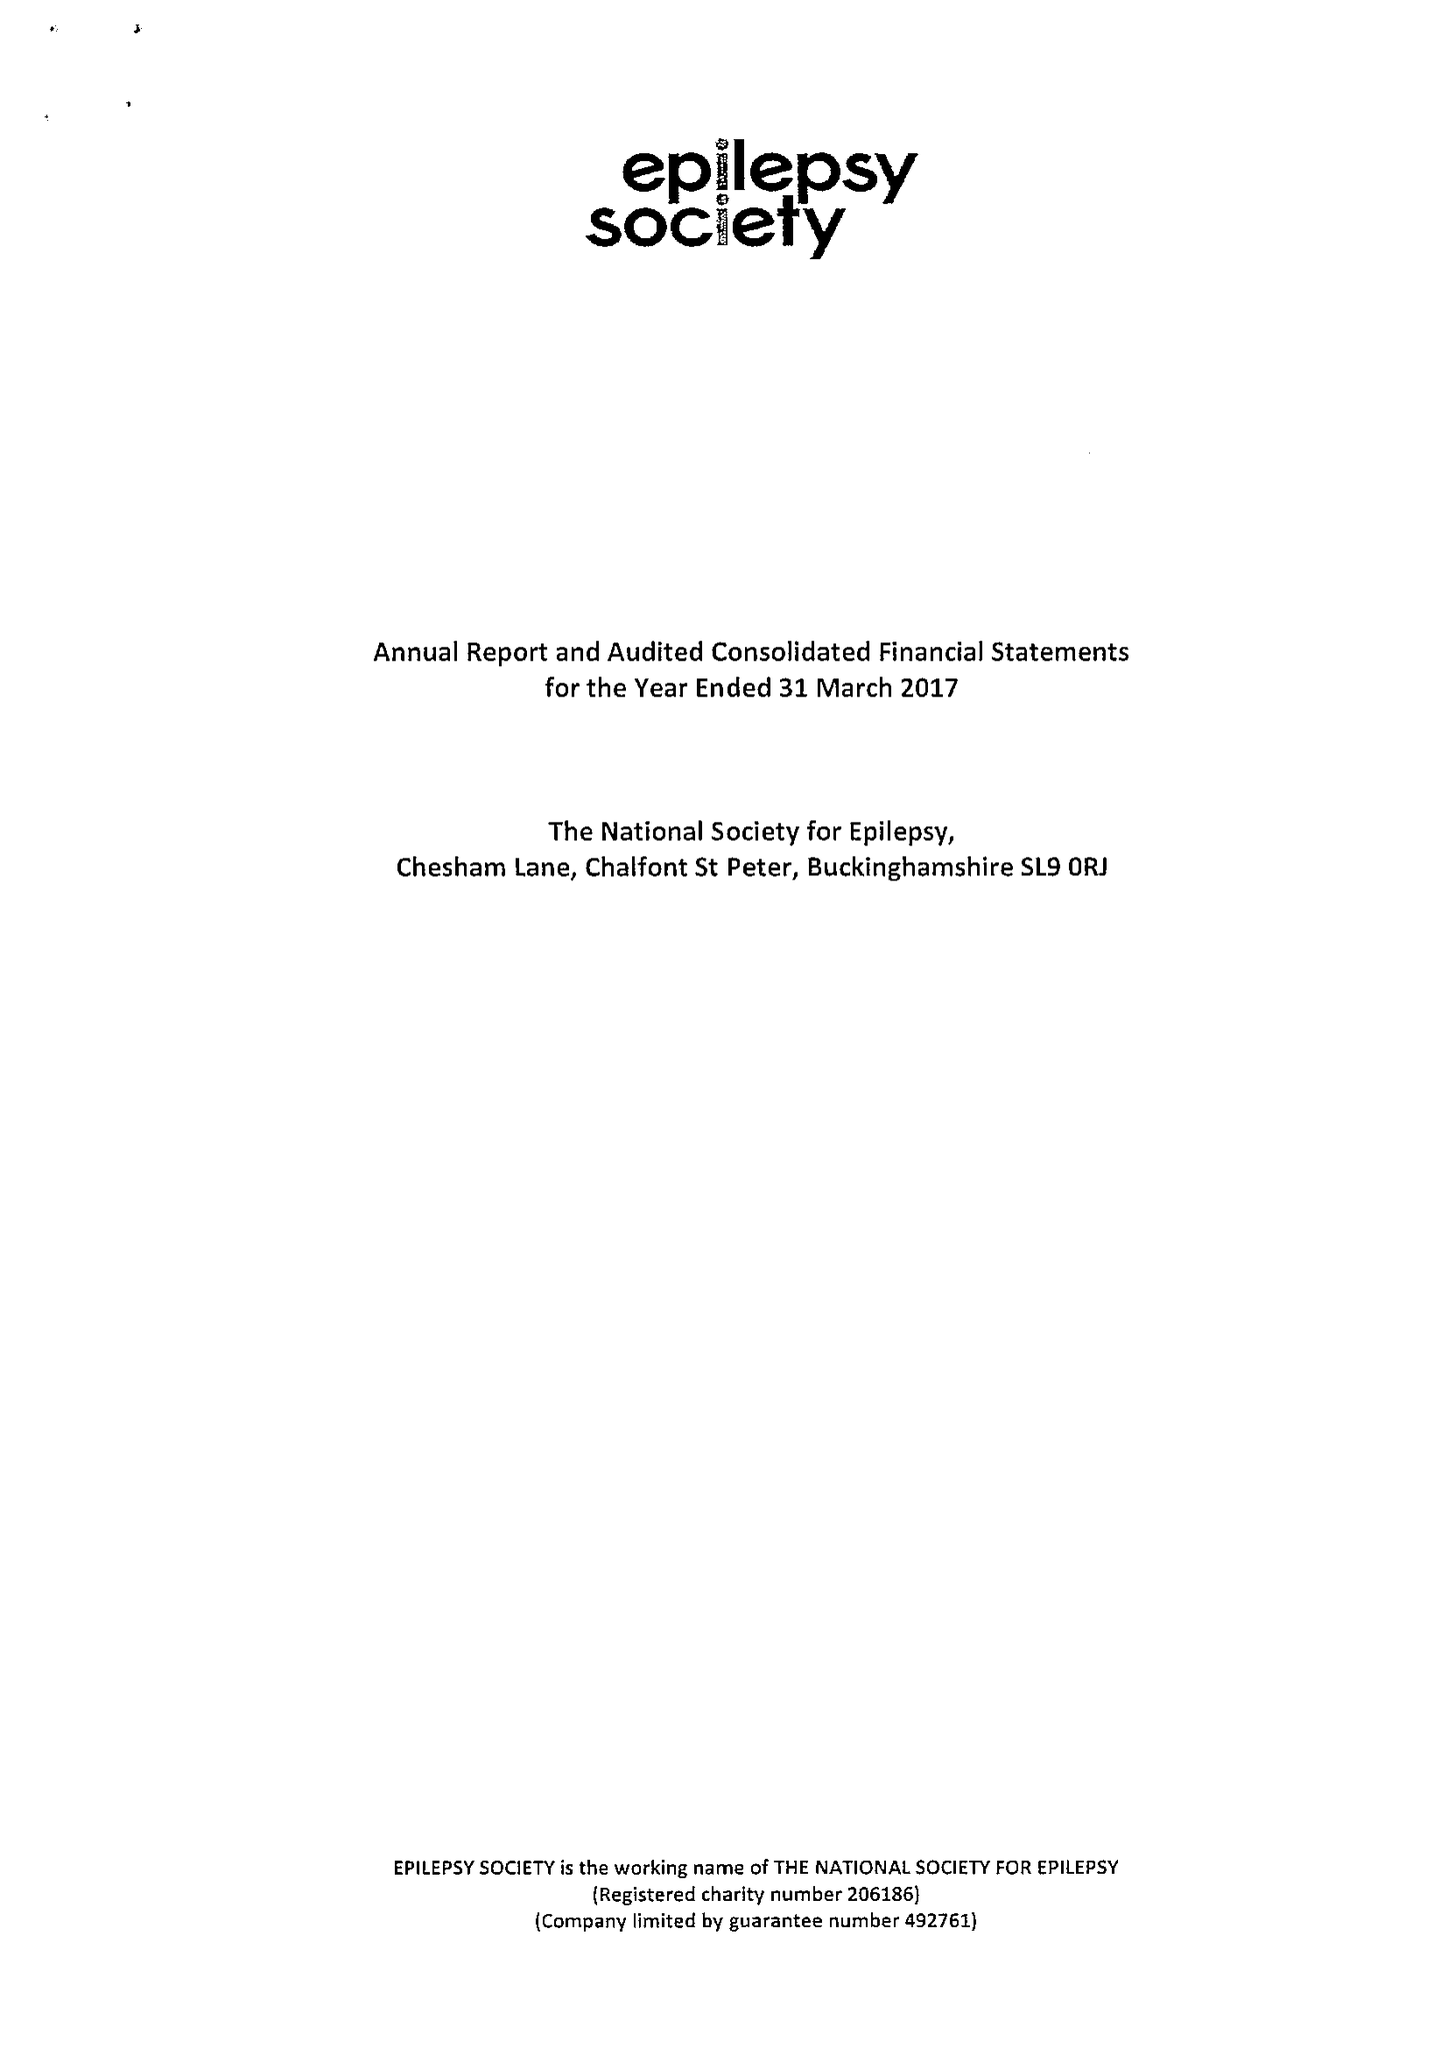What is the value for the charity_number?
Answer the question using a single word or phrase. 206186 